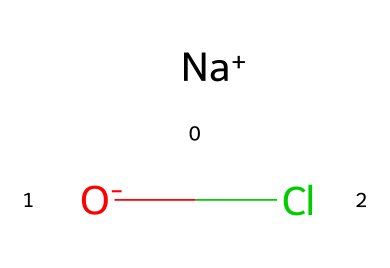what is the central atom in this chemical? The chemical has a chlorine atom present, which is the central atom used for disinfection purposes.
Answer: chlorine how many atoms are present in this molecule? The chemical consists of three atoms: one sodium atom, one chlorine atom, and one oxygen atom, making a total of three.
Answer: three what type of bond is present between sodium and chlorine? The bond is an ionic bond, as sodium (a metal) donates an electron to chlorine (a halogen), creating charged ions that attract each other.
Answer: ionic what is the formal charge on the chlorine atom in this chemical? The chlorine atom has a -1 formal charge, as it gains one electron during the formation of the compound, reflecting its typical behavior as a halogen.
Answer: -1 which part of this chemical primarily contributes to its disinfectant properties? The chlorine atom is primarily responsible for the disinfectant properties due to its ability to react with various pathogens and micro-organisms.
Answer: chlorine what is the oxidation state of chlorine in this compound? In this compound, the oxidation state of chlorine is -1, which is typical for halogens when they gain an electron.
Answer: -1 is this chemical more effective as a disinfectant in acidic or basic conditions? This chemical is generally more effective in low pH (acidic) conditions as chlorine is more stable and reactive under those conditions.
Answer: acidic 